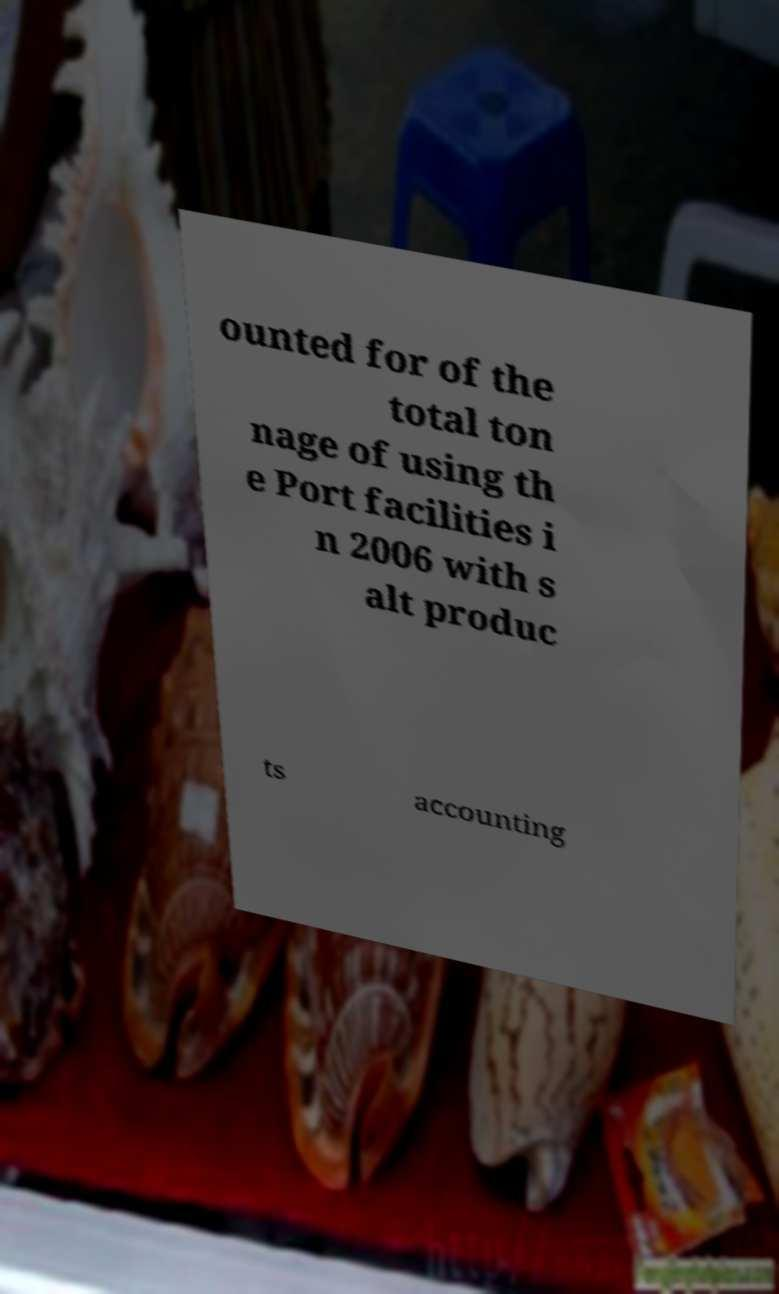Please read and relay the text visible in this image. What does it say? ounted for of the total ton nage of using th e Port facilities i n 2006 with s alt produc ts accounting 